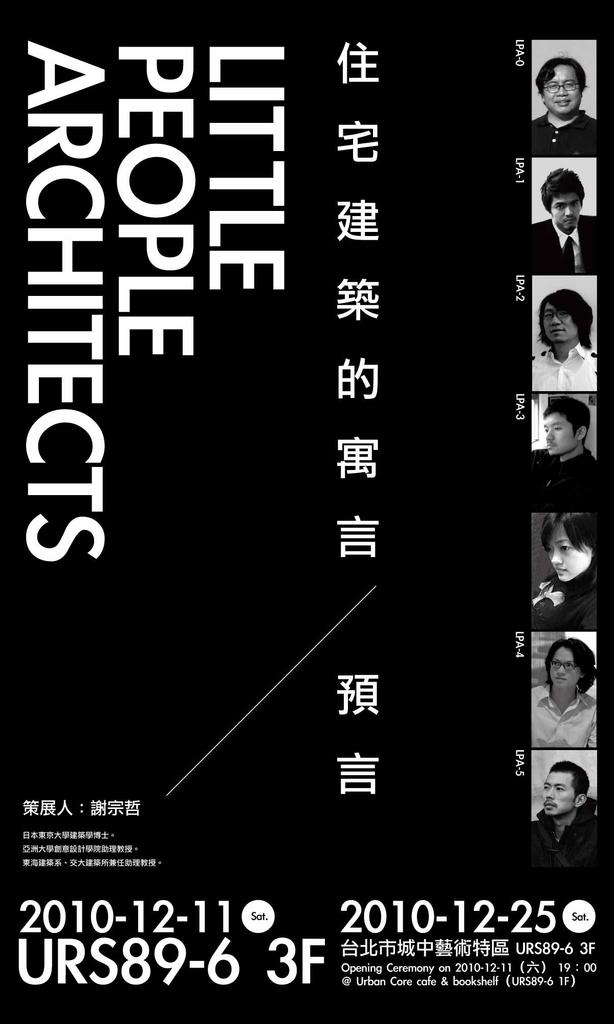<image>
Offer a succinct explanation of the picture presented. An ad for Little People Architects shows pictures of several people. 